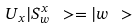Convert formula to latex. <formula><loc_0><loc_0><loc_500><loc_500>U _ { x } | S _ { w } ^ { x } \ > = | w \ ></formula> 